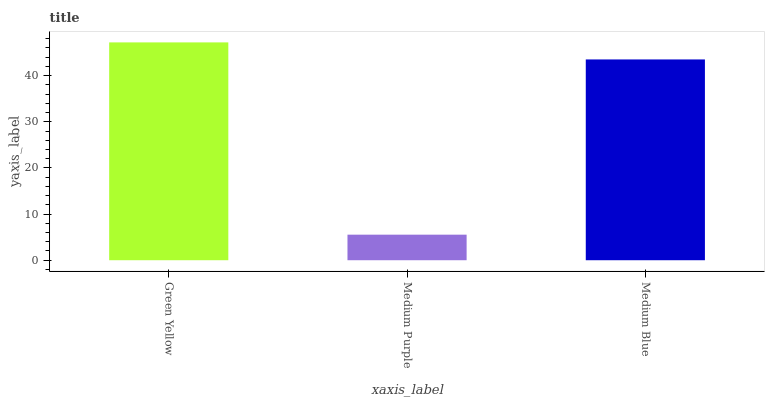Is Medium Blue the minimum?
Answer yes or no. No. Is Medium Blue the maximum?
Answer yes or no. No. Is Medium Blue greater than Medium Purple?
Answer yes or no. Yes. Is Medium Purple less than Medium Blue?
Answer yes or no. Yes. Is Medium Purple greater than Medium Blue?
Answer yes or no. No. Is Medium Blue less than Medium Purple?
Answer yes or no. No. Is Medium Blue the high median?
Answer yes or no. Yes. Is Medium Blue the low median?
Answer yes or no. Yes. Is Green Yellow the high median?
Answer yes or no. No. Is Medium Purple the low median?
Answer yes or no. No. 